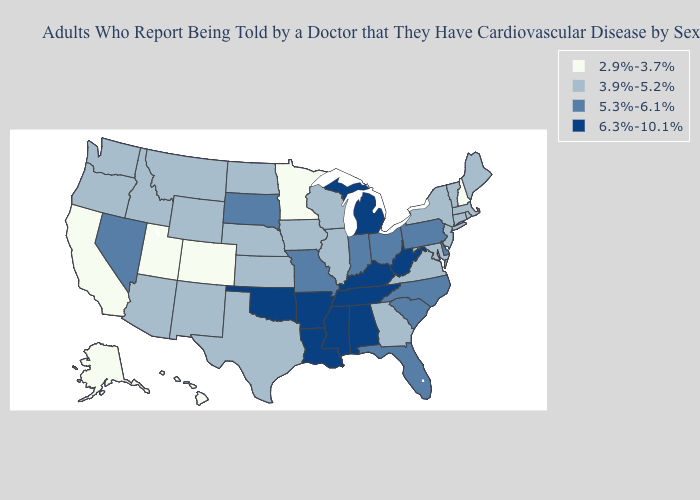Among the states that border Utah , which have the highest value?
Be succinct. Nevada. What is the highest value in the South ?
Quick response, please. 6.3%-10.1%. Among the states that border Missouri , which have the highest value?
Answer briefly. Arkansas, Kentucky, Oklahoma, Tennessee. Name the states that have a value in the range 3.9%-5.2%?
Short answer required. Arizona, Connecticut, Georgia, Idaho, Illinois, Iowa, Kansas, Maine, Maryland, Massachusetts, Montana, Nebraska, New Jersey, New Mexico, New York, North Dakota, Oregon, Rhode Island, Texas, Vermont, Virginia, Washington, Wisconsin, Wyoming. Does the map have missing data?
Give a very brief answer. No. Name the states that have a value in the range 3.9%-5.2%?
Be succinct. Arizona, Connecticut, Georgia, Idaho, Illinois, Iowa, Kansas, Maine, Maryland, Massachusetts, Montana, Nebraska, New Jersey, New Mexico, New York, North Dakota, Oregon, Rhode Island, Texas, Vermont, Virginia, Washington, Wisconsin, Wyoming. Name the states that have a value in the range 6.3%-10.1%?
Keep it brief. Alabama, Arkansas, Kentucky, Louisiana, Michigan, Mississippi, Oklahoma, Tennessee, West Virginia. What is the lowest value in the Northeast?
Quick response, please. 2.9%-3.7%. Does California have the highest value in the USA?
Answer briefly. No. What is the value of Utah?
Give a very brief answer. 2.9%-3.7%. Among the states that border Tennessee , which have the highest value?
Give a very brief answer. Alabama, Arkansas, Kentucky, Mississippi. What is the value of Colorado?
Be succinct. 2.9%-3.7%. Does the map have missing data?
Short answer required. No. What is the lowest value in the Northeast?
Keep it brief. 2.9%-3.7%. Name the states that have a value in the range 3.9%-5.2%?
Quick response, please. Arizona, Connecticut, Georgia, Idaho, Illinois, Iowa, Kansas, Maine, Maryland, Massachusetts, Montana, Nebraska, New Jersey, New Mexico, New York, North Dakota, Oregon, Rhode Island, Texas, Vermont, Virginia, Washington, Wisconsin, Wyoming. 